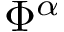<formula> <loc_0><loc_0><loc_500><loc_500>\Phi ^ { \alpha }</formula> 